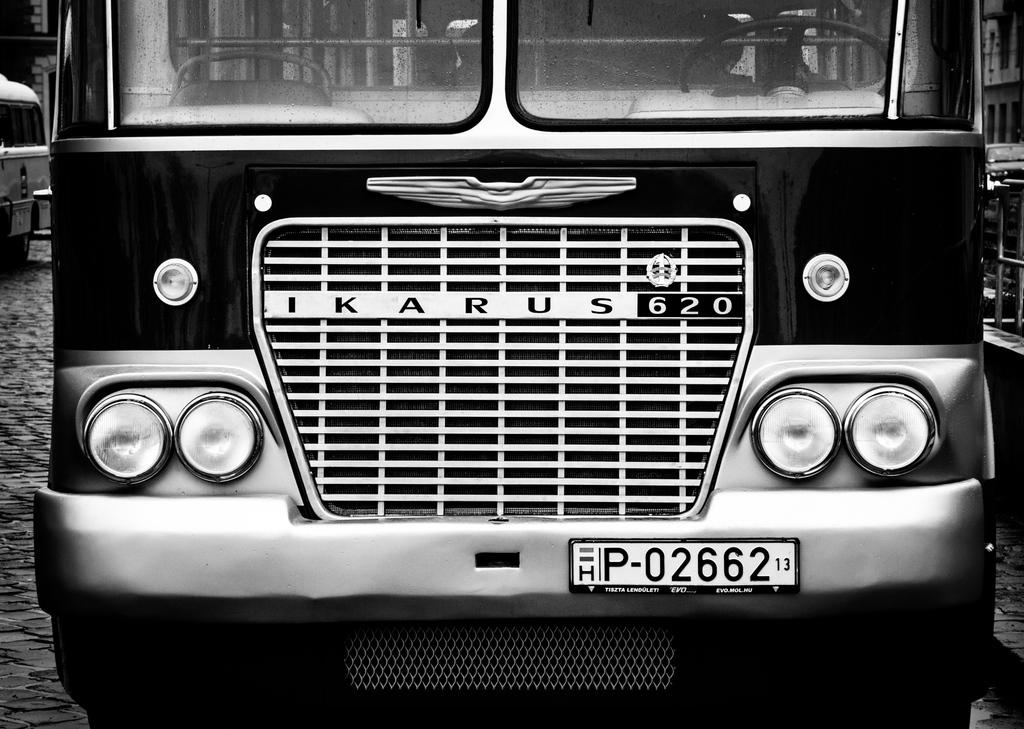What types of objects are present in the image? A: There are vehicles in the image. What specific features can be observed on the vehicles? The vehicles have registration plates and headlights. Can you see any cobwebs on the vehicles in the image? There is no mention of cobwebs in the image, so we cannot determine if they are present or not. 